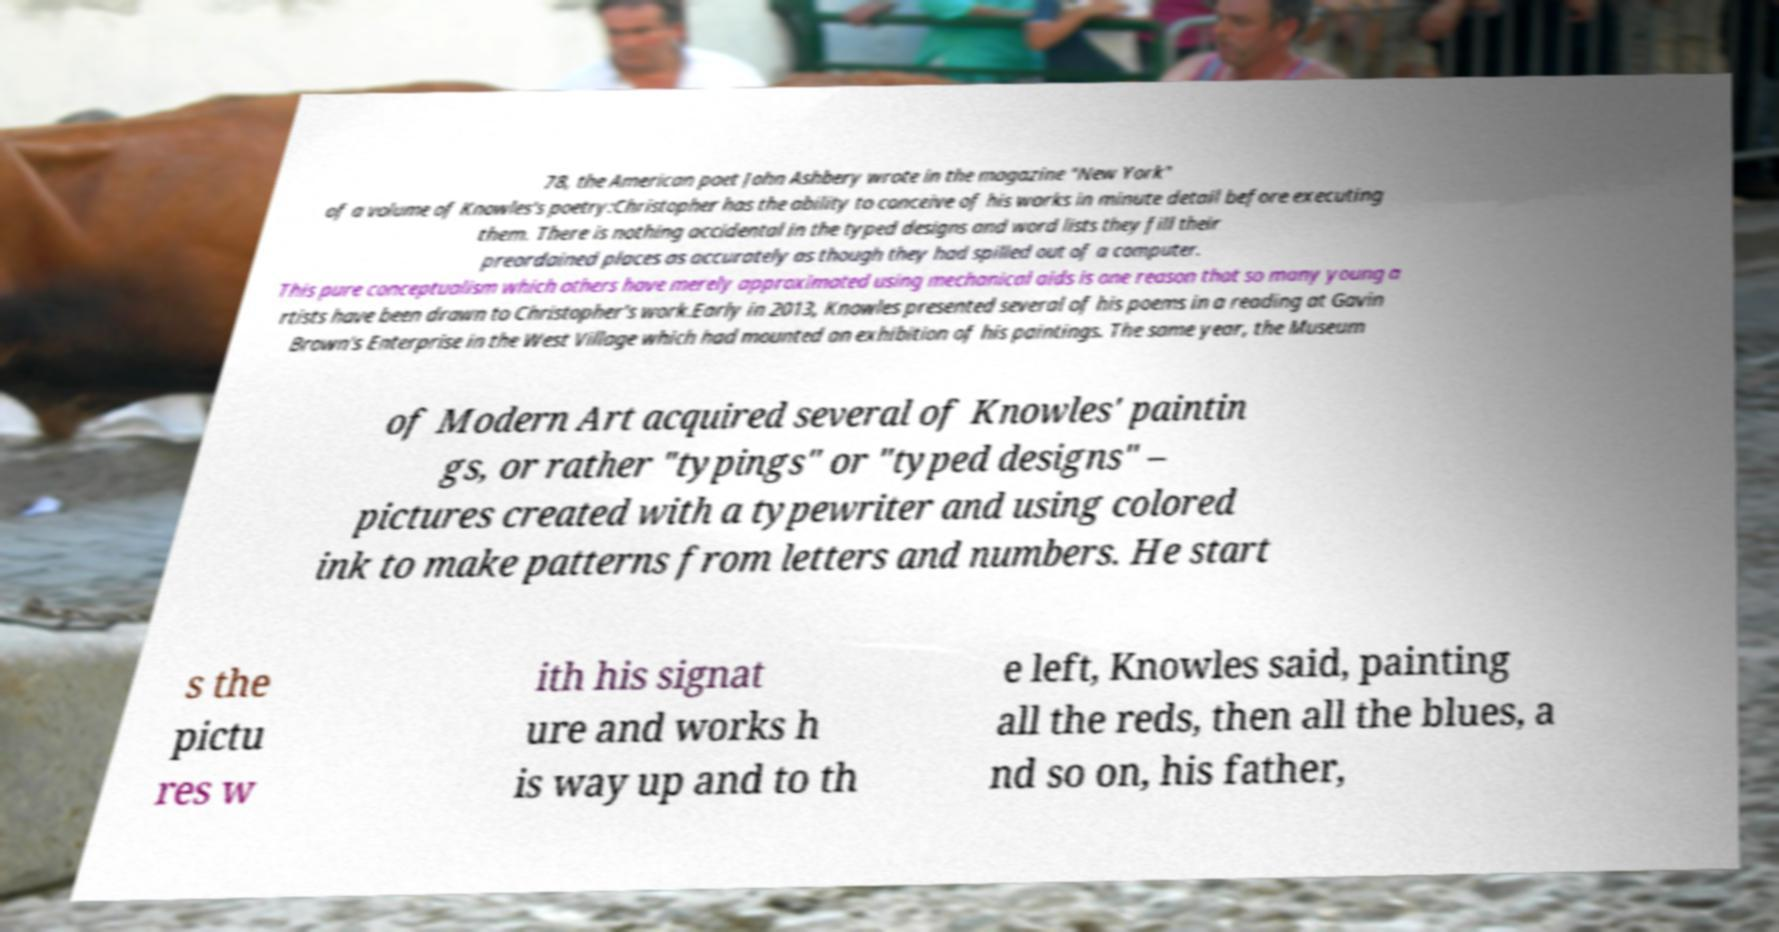Please identify and transcribe the text found in this image. 78, the American poet John Ashbery wrote in the magazine "New York" of a volume of Knowles's poetry:Christopher has the ability to conceive of his works in minute detail before executing them. There is nothing accidental in the typed designs and word lists they fill their preordained places as accurately as though they had spilled out of a computer. This pure conceptualism which others have merely approximated using mechanical aids is one reason that so many young a rtists have been drawn to Christopher's work.Early in 2013, Knowles presented several of his poems in a reading at Gavin Brown's Enterprise in the West Village which had mounted an exhibition of his paintings. The same year, the Museum of Modern Art acquired several of Knowles' paintin gs, or rather "typings" or "typed designs" – pictures created with a typewriter and using colored ink to make patterns from letters and numbers. He start s the pictu res w ith his signat ure and works h is way up and to th e left, Knowles said, painting all the reds, then all the blues, a nd so on, his father, 